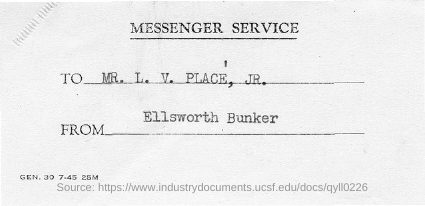Who is the message from?
Your answer should be very brief. ELLSWORTH BUNKER. 